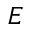Convert formula to latex. <formula><loc_0><loc_0><loc_500><loc_500>E</formula> 